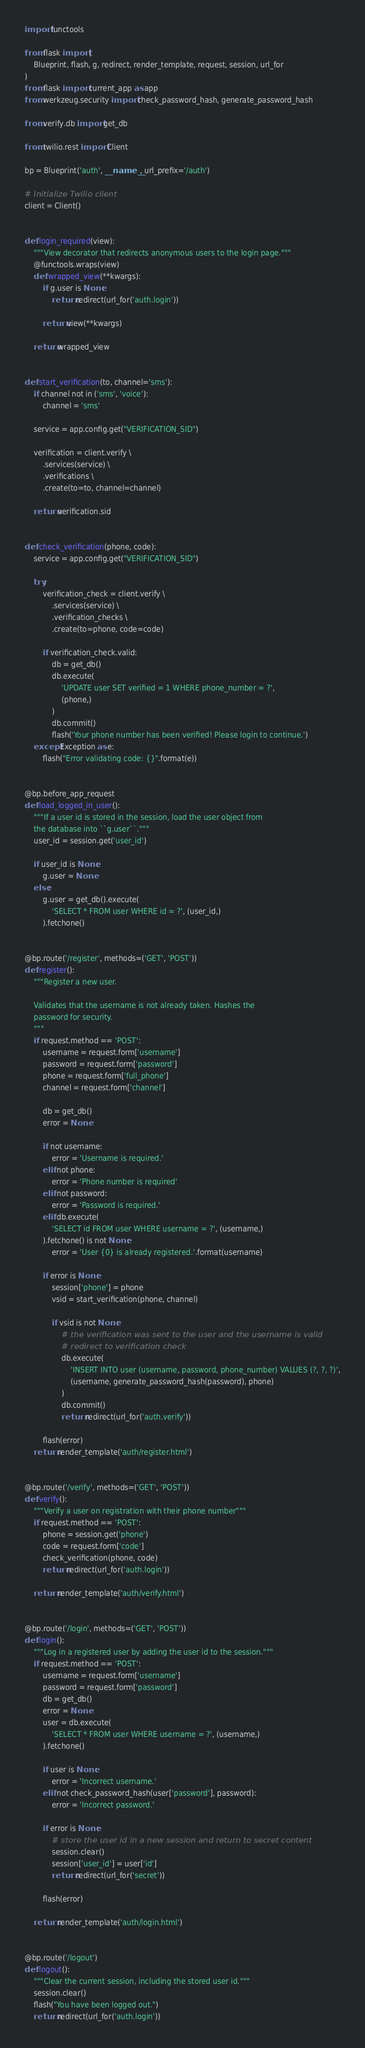Convert code to text. <code><loc_0><loc_0><loc_500><loc_500><_Python_>import functools

from flask import (
    Blueprint, flash, g, redirect, render_template, request, session, url_for
)
from flask import current_app as app
from werkzeug.security import check_password_hash, generate_password_hash

from verify.db import get_db

from twilio.rest import Client

bp = Blueprint('auth', __name__, url_prefix='/auth')

# Initialize Twilio client
client = Client()


def login_required(view):
    """View decorator that redirects anonymous users to the login page."""
    @functools.wraps(view)
    def wrapped_view(**kwargs):
        if g.user is None:
            return redirect(url_for('auth.login'))

        return view(**kwargs)

    return wrapped_view


def start_verification(to, channel='sms'):
    if channel not in ('sms', 'voice'):
        channel = 'sms'

    service = app.config.get("VERIFICATION_SID")

    verification = client.verify \
        .services(service) \
        .verifications \
        .create(to=to, channel=channel)
    
    return verification.sid


def check_verification(phone, code):
    service = app.config.get("VERIFICATION_SID")
    
    try:
        verification_check = client.verify \
            .services(service) \
            .verification_checks \
            .create(to=phone, code=code)

        if verification_check.valid:
            db = get_db()
            db.execute(
                'UPDATE user SET verified = 1 WHERE phone_number = ?', 
                (phone,)
            )
            db.commit()
            flash('Your phone number has been verified! Please login to continue.')
    except Exception as e:
        flash("Error validating code: {}".format(e))


@bp.before_app_request
def load_logged_in_user():
    """If a user id is stored in the session, load the user object from
    the database into ``g.user``."""
    user_id = session.get('user_id')

    if user_id is None:
        g.user = None
    else:
        g.user = get_db().execute(
            'SELECT * FROM user WHERE id = ?', (user_id,)
        ).fetchone()


@bp.route('/register', methods=('GET', 'POST'))
def register():
    """Register a new user.

    Validates that the username is not already taken. Hashes the
    password for security.
    """
    if request.method == 'POST':
        username = request.form['username']
        password = request.form['password']
        phone = request.form['full_phone']
        channel = request.form['channel']
        
        db = get_db()
        error = None

        if not username:
            error = 'Username is required.'
        elif not phone:
            error = 'Phone number is required'
        elif not password:
            error = 'Password is required.'
        elif db.execute(
            'SELECT id FROM user WHERE username = ?', (username,)
        ).fetchone() is not None:
            error = 'User {0} is already registered.'.format(username)

        if error is None:
            session['phone'] = phone
            vsid = start_verification(phone, channel)

            if vsid is not None:
                # the verification was sent to the user and the username is valid
                # redirect to verification check
                db.execute(
                    'INSERT INTO user (username, password, phone_number) VALUES (?, ?, ?)',
                    (username, generate_password_hash(password), phone)
                )
                db.commit()
                return redirect(url_for('auth.verify'))

        flash(error)
    return render_template('auth/register.html')


@bp.route('/verify', methods=('GET', 'POST'))
def verify():
    """Verify a user on registration with their phone number"""
    if request.method == 'POST':
        phone = session.get('phone')
        code = request.form['code']
        check_verification(phone, code)
        return redirect(url_for('auth.login'))

    return render_template('auth/verify.html')


@bp.route('/login', methods=('GET', 'POST'))
def login():
    """Log in a registered user by adding the user id to the session."""
    if request.method == 'POST':
        username = request.form['username']
        password = request.form['password']
        db = get_db()
        error = None
        user = db.execute(
            'SELECT * FROM user WHERE username = ?', (username,)
        ).fetchone()

        if user is None:
            error = 'Incorrect username.'
        elif not check_password_hash(user['password'], password):
            error = 'Incorrect password.'

        if error is None:
            # store the user id in a new session and return to secret content
            session.clear()
            session['user_id'] = user['id']
            return redirect(url_for('secret'))

        flash(error)

    return render_template('auth/login.html')


@bp.route('/logout')
def logout():
    """Clear the current session, including the stored user id."""
    session.clear()
    flash("You have been logged out.")
    return redirect(url_for('auth.login'))
</code> 